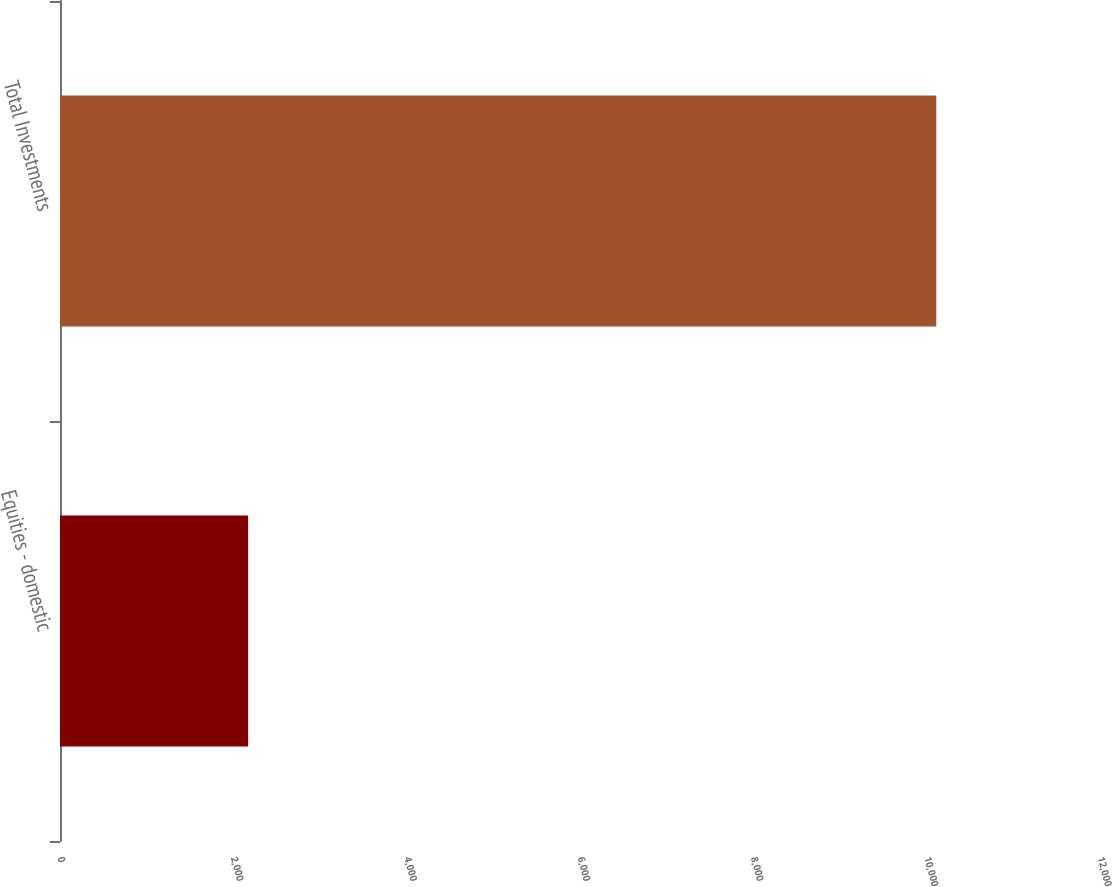Convert chart. <chart><loc_0><loc_0><loc_500><loc_500><bar_chart><fcel>Equities - domestic<fcel>Total Investments<nl><fcel>2171<fcel>10111<nl></chart> 